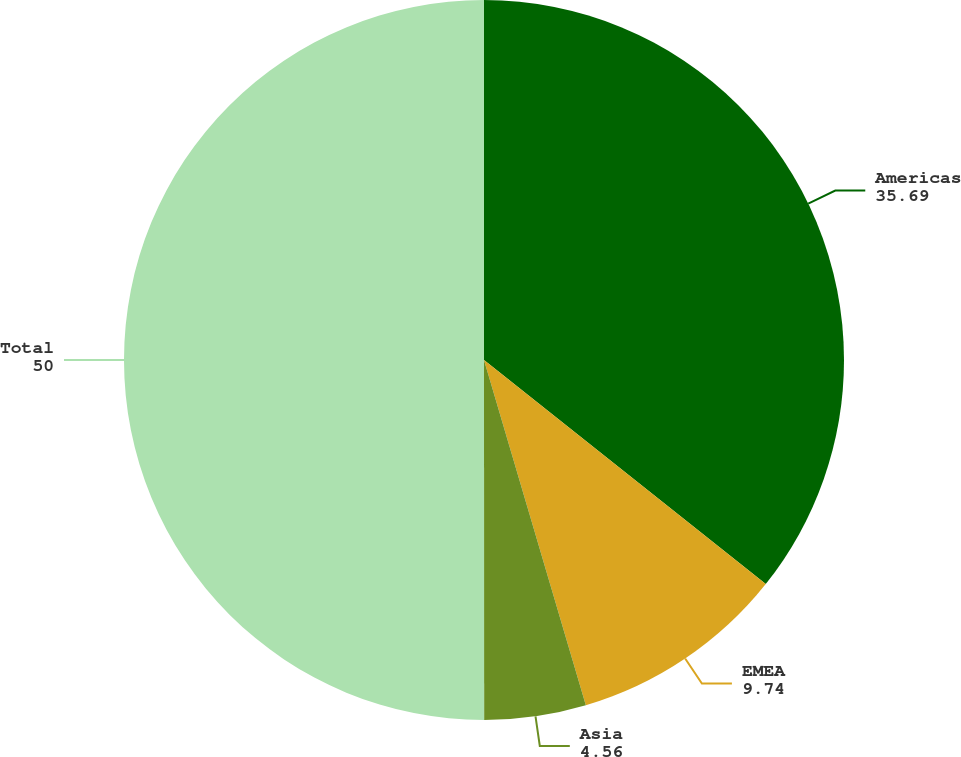<chart> <loc_0><loc_0><loc_500><loc_500><pie_chart><fcel>Americas<fcel>EMEA<fcel>Asia<fcel>Total<nl><fcel>35.69%<fcel>9.74%<fcel>4.56%<fcel>50.0%<nl></chart> 